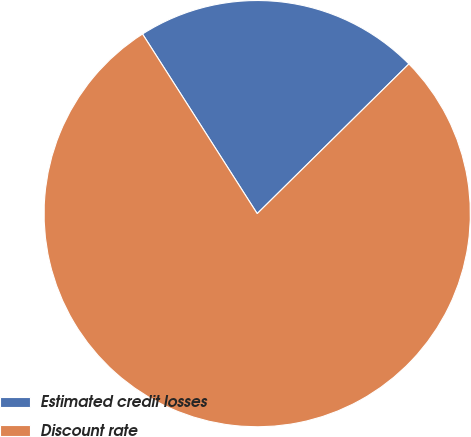<chart> <loc_0><loc_0><loc_500><loc_500><pie_chart><fcel>Estimated credit losses<fcel>Discount rate<nl><fcel>21.65%<fcel>78.35%<nl></chart> 